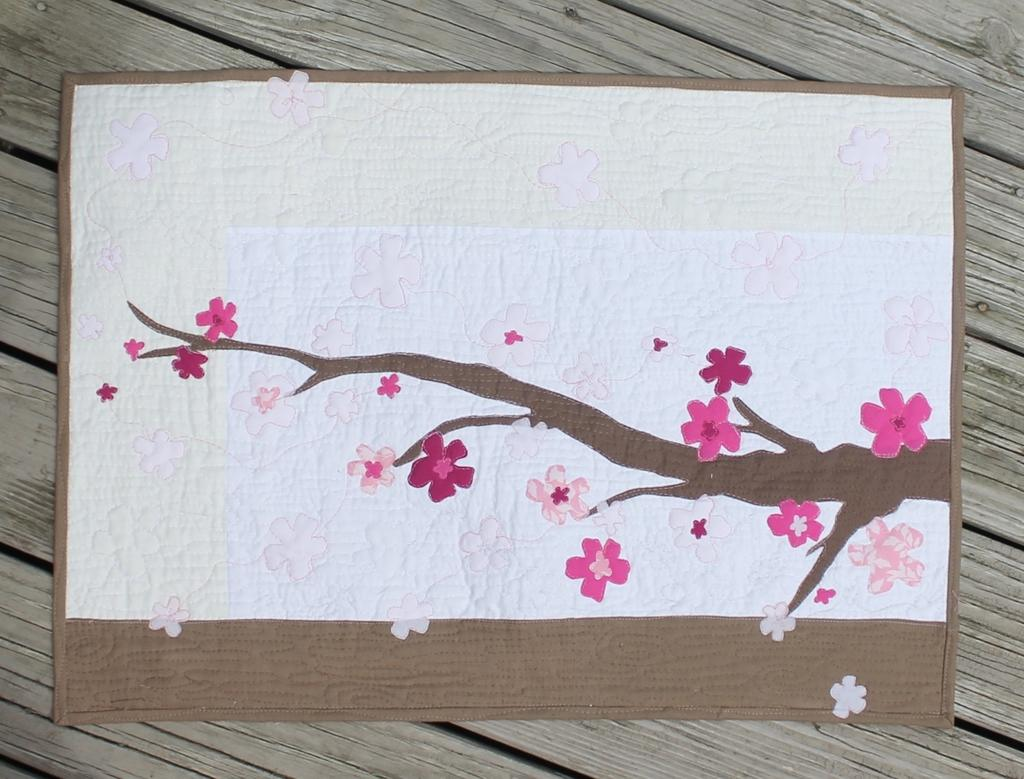What is placed on a wooden object in the image? There is a floor mat in the image, and it is placed on a wooden object. What type of fiction is being read by the flame in the image? There is no fiction or flame present in the image; it only features a floor mat on a wooden object. 